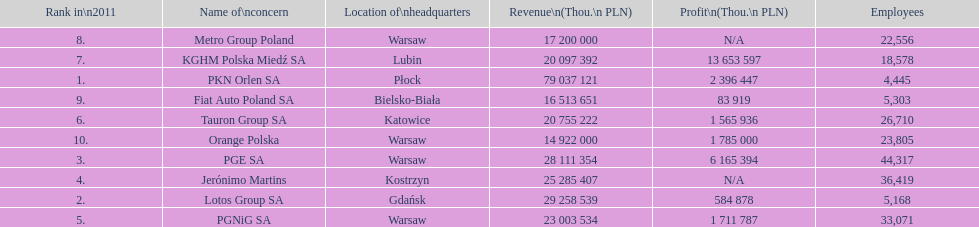Could you parse the entire table as a dict? {'header': ['Rank in\\n2011', 'Name of\\nconcern', 'Location of\\nheadquarters', 'Revenue\\n(Thou.\\n\xa0PLN)', 'Profit\\n(Thou.\\n\xa0PLN)', 'Employees'], 'rows': [['8.', 'Metro Group Poland', 'Warsaw', '17 200 000', 'N/A', '22,556'], ['7.', 'KGHM Polska Miedź SA', 'Lubin', '20 097 392', '13 653 597', '18,578'], ['1.', 'PKN Orlen SA', 'Płock', '79 037 121', '2 396 447', '4,445'], ['9.', 'Fiat Auto Poland SA', 'Bielsko-Biała', '16 513 651', '83 919', '5,303'], ['6.', 'Tauron Group SA', 'Katowice', '20 755 222', '1 565 936', '26,710'], ['10.', 'Orange Polska', 'Warsaw', '14 922 000', '1 785 000', '23,805'], ['3.', 'PGE SA', 'Warsaw', '28 111 354', '6 165 394', '44,317'], ['4.', 'Jerónimo Martins', 'Kostrzyn', '25 285 407', 'N/A', '36,419'], ['2.', 'Lotos Group SA', 'Gdańsk', '29 258 539', '584 878', '5,168'], ['5.', 'PGNiG SA', 'Warsaw', '23 003 534', '1 711 787', '33,071']]} Which company had the most employees? PGE SA. 